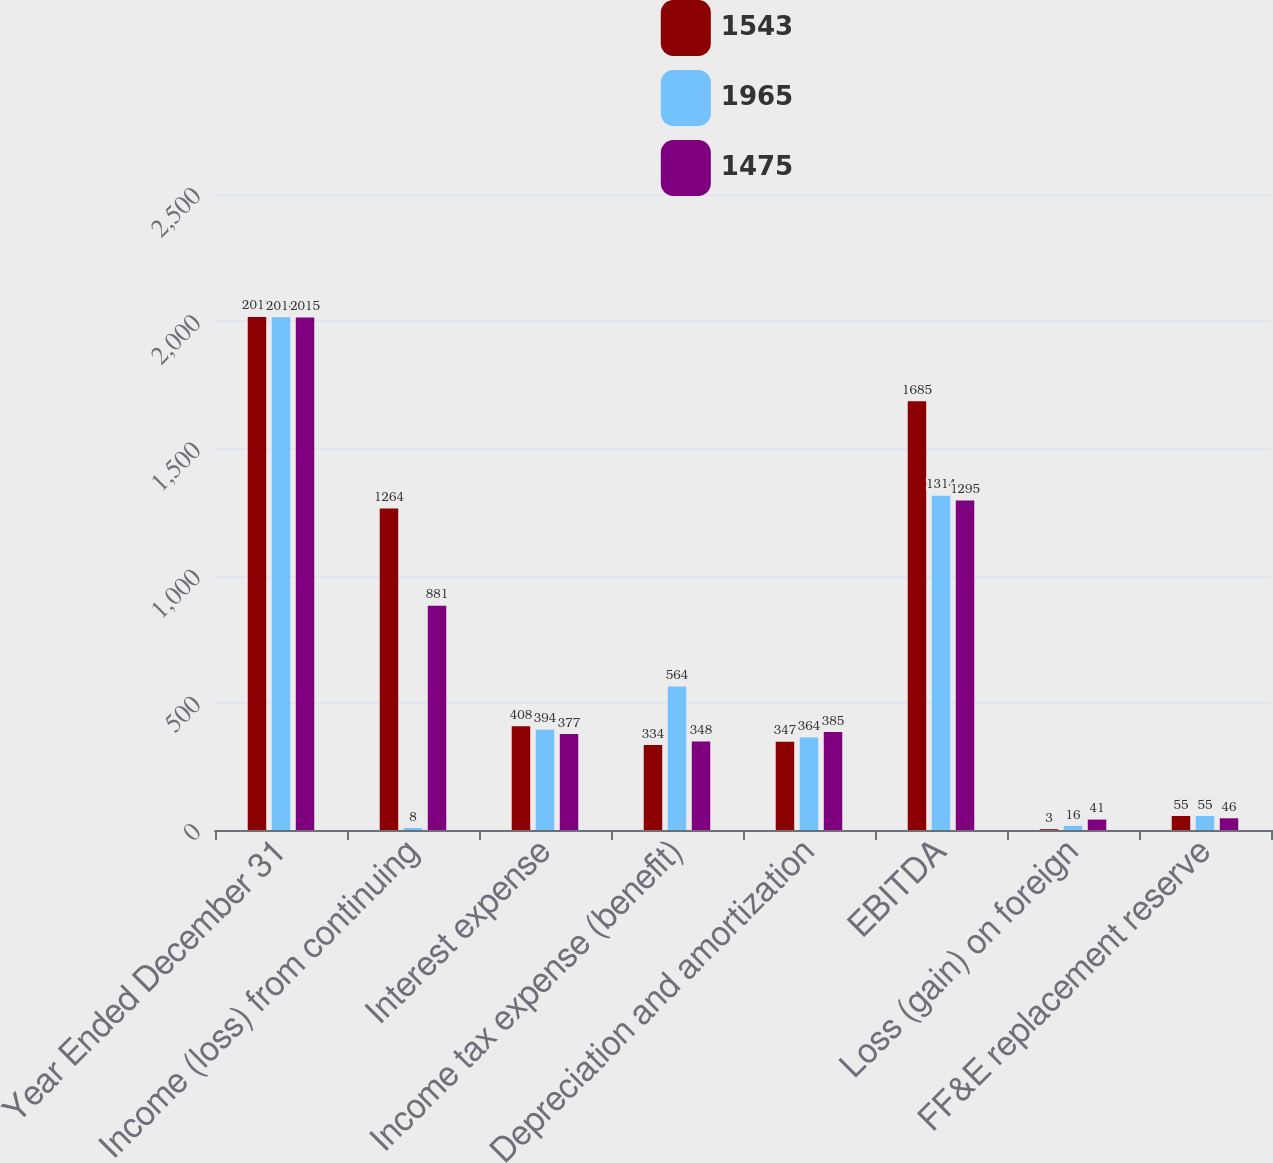<chart> <loc_0><loc_0><loc_500><loc_500><stacked_bar_chart><ecel><fcel>Year Ended December 31<fcel>Income (loss) from continuing<fcel>Interest expense<fcel>Income tax expense (benefit)<fcel>Depreciation and amortization<fcel>EBITDA<fcel>Loss (gain) on foreign<fcel>FF&E replacement reserve<nl><fcel>1543<fcel>2017<fcel>1264<fcel>408<fcel>334<fcel>347<fcel>1685<fcel>3<fcel>55<nl><fcel>1965<fcel>2016<fcel>8<fcel>394<fcel>564<fcel>364<fcel>1314<fcel>16<fcel>55<nl><fcel>1475<fcel>2015<fcel>881<fcel>377<fcel>348<fcel>385<fcel>1295<fcel>41<fcel>46<nl></chart> 